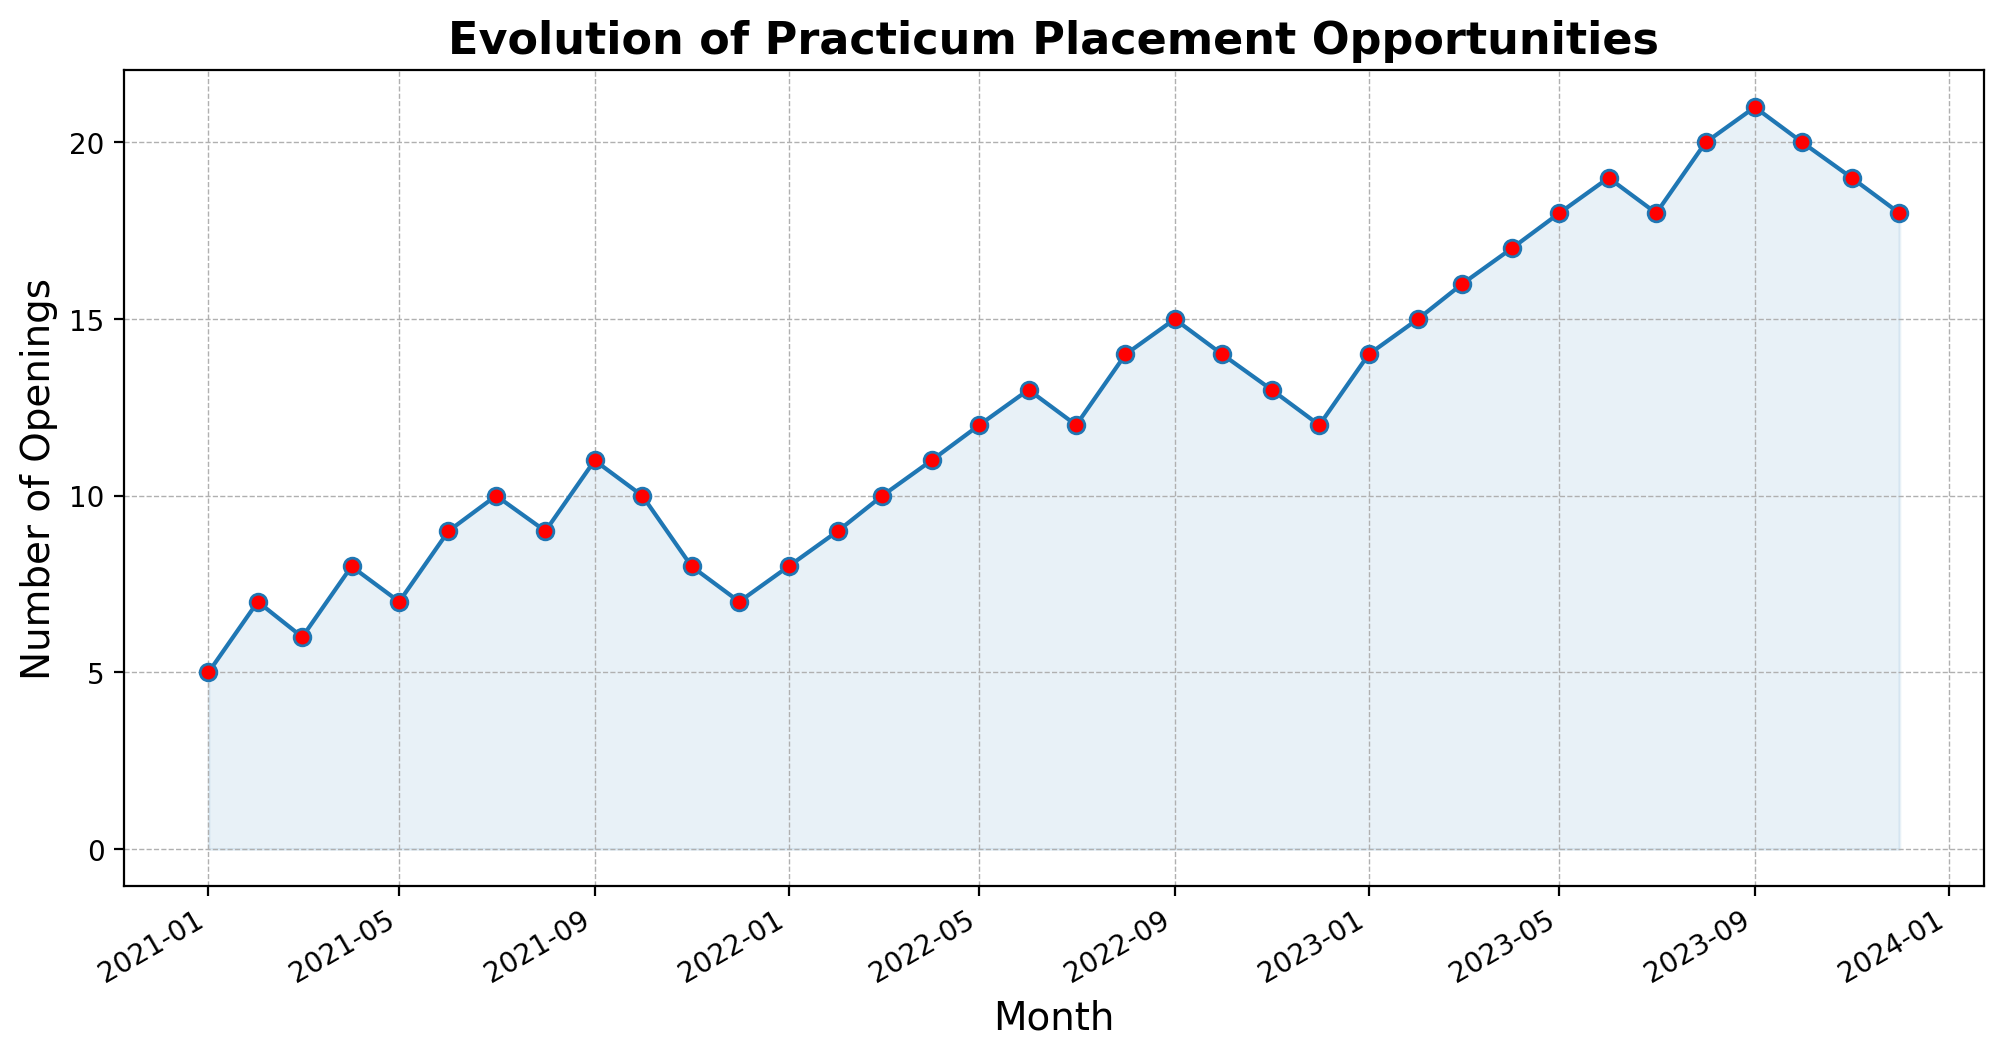What is the overall trend of practicum placement opportunities over the past 3 years? Observing the plot, the overall number of openings shows a consistent upward trend from the start of 2021 to the end of 2023. This trend indicates a gradual increase in placement opportunities over the past three years.
Answer: Upward By how much did the number of openings increase from January 2021 to January 2023? In January 2021, there were 5 openings, and by January 2023, the openings increased to 14. The difference between these two values gives an increase of 14 - 5 = 9 openings.
Answer: 9 openings Which month in 2023 had the highest number of practicum placement opportunities? In 2023, the highest number of openings occurred in September, with a total of 21 openings, as shown by the peak in the graph.
Answer: September 2023 Is there any month that experienced a consistent decline in the number of openings each year? By looking at the plot, December shows a consistent decline in the number of openings each year, from 7 in 2021 to 12 in 2022, and 18 in 2023.
Answer: December What was the highest number of practicum placements in 2022, and in which month did it occur? The highest number of openings in 2022 occurred in September, with a total of 15 openings. This can be identified by locating the tallest point on the plot in the year 2022.
Answer: 15 in September Compare the number of openings in June for each of the three years. Was there an increase or decrease each year? June 2021 had 9 openings, June 2022 had 13 openings, and June 2023 had 19 openings. Each year, there is an increase in the number of openings by 4 from 2021 to 2022, and 6 from 2022 to 2023.
Answer: Increase each year What can you infer about the month of August for the years 2021, 2022, and 2023 on the practicum placements? In August 2021, the number of openings was 9, which increased to 14 in August 2022, and further increased to 20 in August 2023. This shows a growing trend in practicum placement opportunities each August over the three years.
Answer: Increasing trend Which year saw the biggest jump in practicum placements from the beginning to the end of the year? Comparing the differences from the beginning to the end of each year: 
- 2021: 7 - 5 = 2
- 2022: 12 - 8 = 4
- 2023: 18 - 14 = 4 
Both 2022 and 2023 had the biggest jumps with a change of 4 openings each year.
Answer: 2022 and 2023 During which month did the number of openings peak in 2021, and what was the count? The number of openings peaked in September 2021, with a count of 11 openings, as identified by the highest point on the plot for that year.
Answer: September 2021, 11 openings How did the number of openings change from February 2023 to March 2023? Observing the plot, the number of openings increased from 15 in February 2023 to 16 in March 2023, indicating a rise of 1 opening.
Answer: Increased by 1 opening 